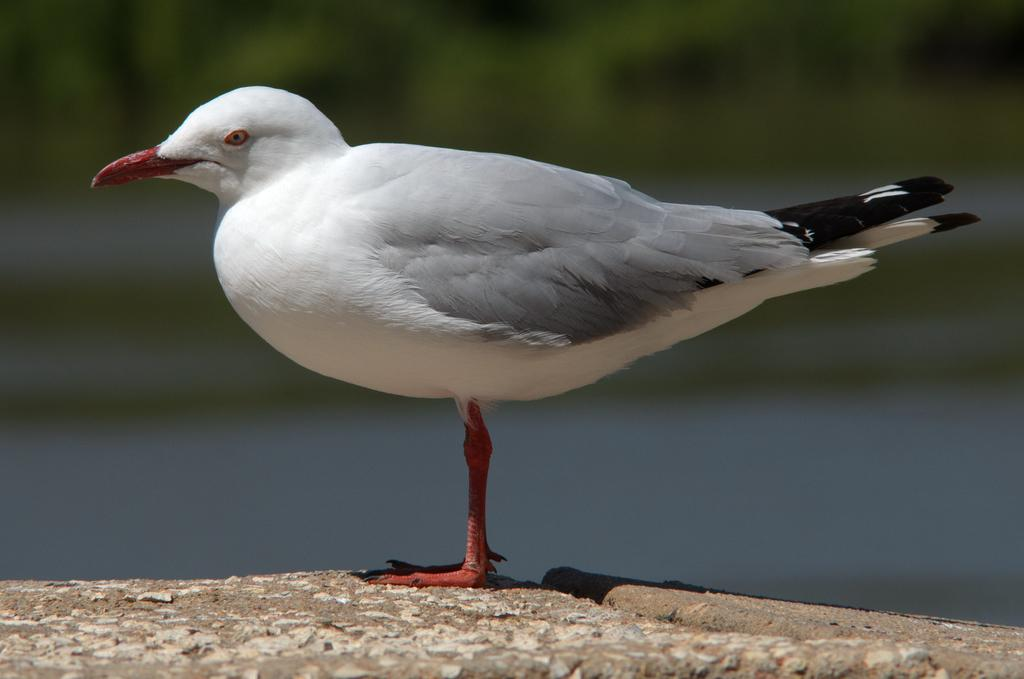What type of animal is in the image? There is a bird in the image. Can you describe the colors of the bird? The bird has white, ash, black, and red colors. Where is the bird located in the image? The bird is standing on the ground. What can be seen in the background of the image? There are trees visible in the background of the image. Are there any other objects visible in the background? Yes, there are other blurry objects in the background of the image. How does the bird provide financial support in the image? The bird does not provide financial support in the image; it is a bird and not a person or entity capable of providing financial support. 